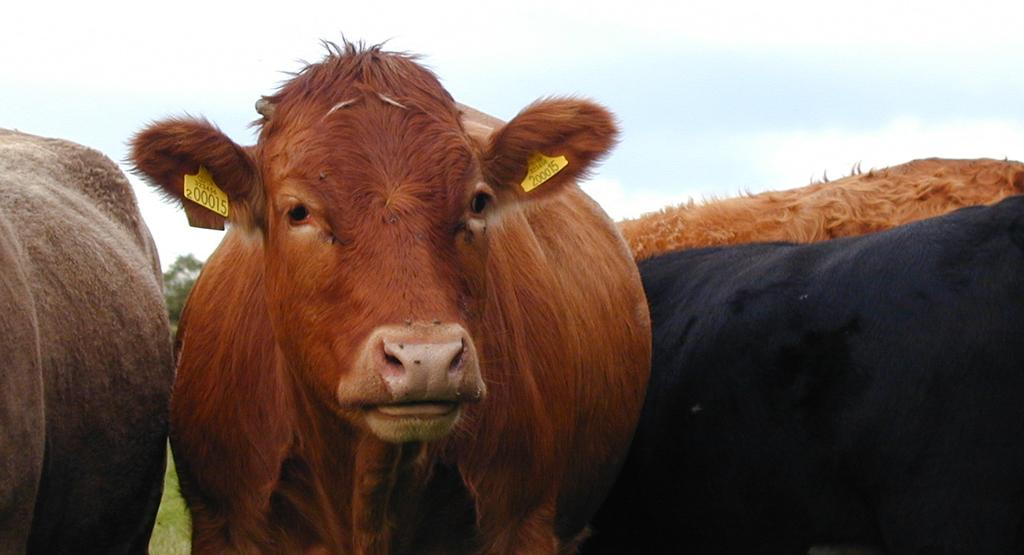What animals can be seen in the image? There are cows in the image. What type of vegetation is visible in the background of the image? There is a tree in the background of the image. What can be seen in the sky in the image? The sky is visible in the background of the image. What type of ground is present at the bottom of the image? There is grass at the bottom of the image. How many dogs are sitting on the pan in the image? There are no dogs or pans present in the image. 